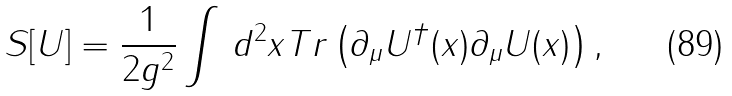Convert formula to latex. <formula><loc_0><loc_0><loc_500><loc_500>\, S [ U ] = \frac { 1 } { 2 g ^ { 2 } } \int \, d ^ { 2 } x T r \left ( \partial _ { \mu } U ^ { \dagger } ( x ) \partial _ { \mu } U ( x ) \right ) ,</formula> 